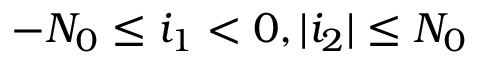Convert formula to latex. <formula><loc_0><loc_0><loc_500><loc_500>- N _ { 0 } \leq i _ { 1 } < 0 , | i _ { 2 } | \leq N _ { 0 }</formula> 